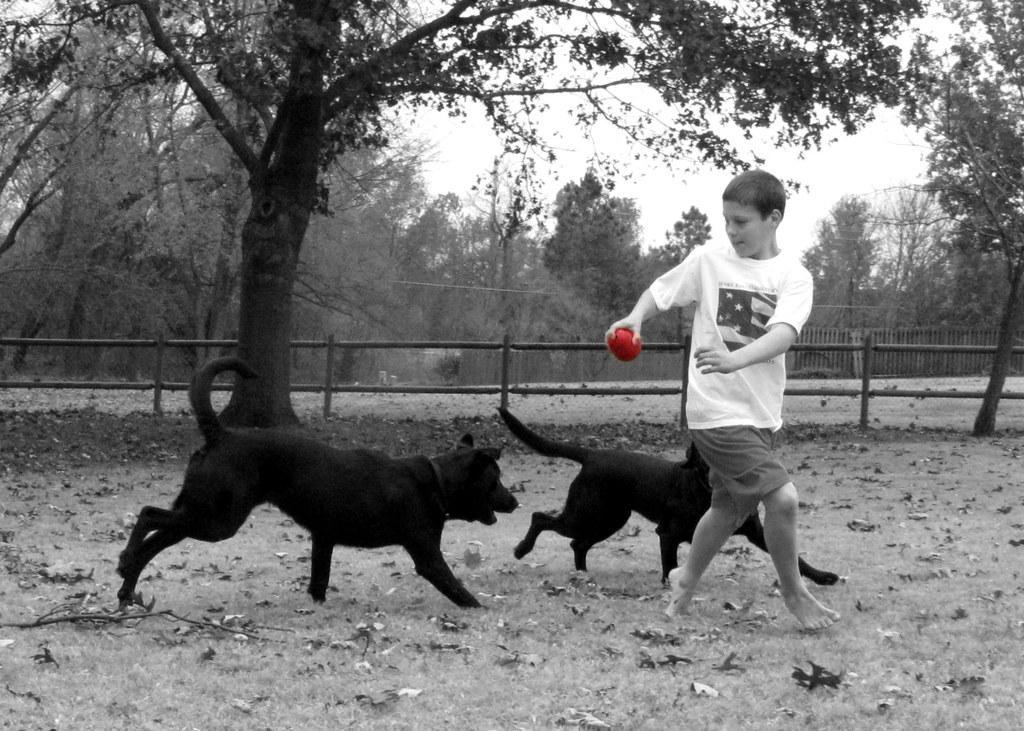Can you describe this image briefly? In this image there is a kid wearing white color dress holding a ball in his hands and there are two dogs running on the floor and at the background of the image there is a fencing and trees. 